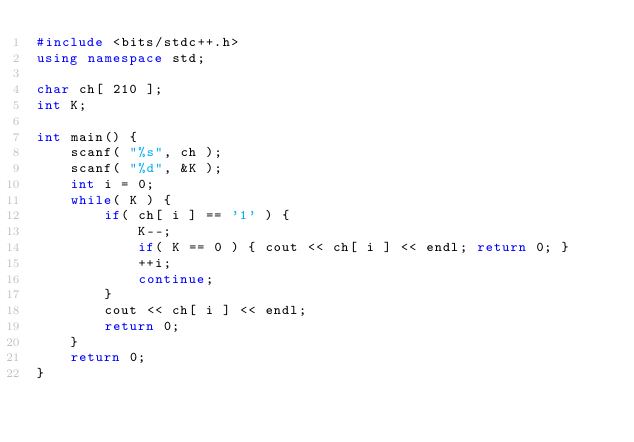Convert code to text. <code><loc_0><loc_0><loc_500><loc_500><_C++_>#include <bits/stdc++.h>
using namespace std;

char ch[ 210 ];
int K;

int main() {
    scanf( "%s", ch );
    scanf( "%d", &K );
    int i = 0;
    while( K ) {
        if( ch[ i ] == '1' ) {
            K--; 
            if( K == 0 ) { cout << ch[ i ] << endl; return 0; }
            ++i;
            continue;
        }
        cout << ch[ i ] << endl;
        return 0;
    }
    return 0;
}</code> 